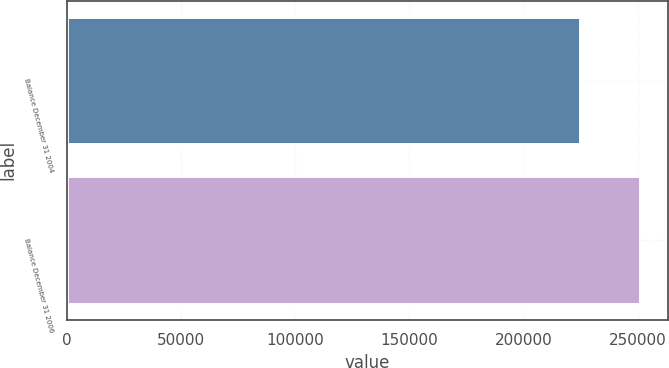<chart> <loc_0><loc_0><loc_500><loc_500><bar_chart><fcel>Balance December 31 2004<fcel>Balance December 31 2006<nl><fcel>224854<fcel>250870<nl></chart> 